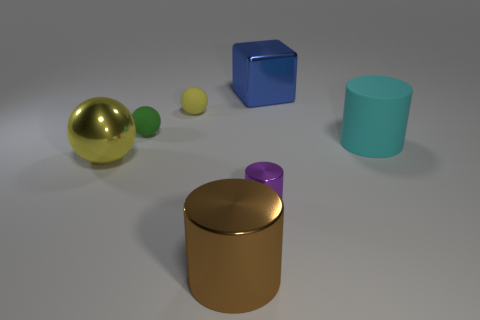The block has what size?
Ensure brevity in your answer.  Large. What material is the yellow object that is behind the cylinder that is behind the tiny thing that is in front of the cyan thing?
Provide a succinct answer. Rubber. What number of other objects are there of the same color as the small metallic thing?
Make the answer very short. 0. How many blue things are either big objects or large metallic spheres?
Offer a very short reply. 1. There is a big cylinder that is on the left side of the big blue metallic block; what is it made of?
Make the answer very short. Metal. Is the material of the large cylinder that is to the right of the small cylinder the same as the green thing?
Ensure brevity in your answer.  Yes. What shape is the large cyan rubber thing?
Provide a succinct answer. Cylinder. What number of objects are to the right of the yellow ball to the left of the matte object behind the green sphere?
Your response must be concise. 6. How many other things are the same material as the brown thing?
Your answer should be very brief. 3. There is a yellow thing that is the same size as the cyan cylinder; what is it made of?
Offer a very short reply. Metal. 